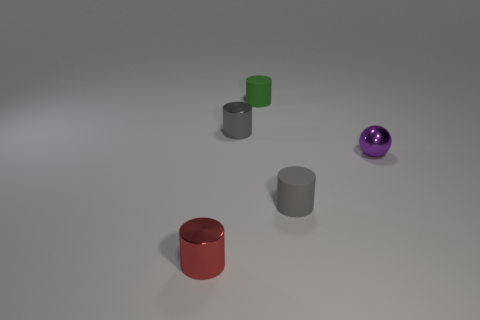Subtract all tiny gray metal cylinders. How many cylinders are left? 3 Subtract all brown blocks. How many gray cylinders are left? 2 Subtract all red cylinders. How many cylinders are left? 3 Subtract all cylinders. How many objects are left? 1 Add 2 shiny things. How many objects exist? 7 Subtract 0 red spheres. How many objects are left? 5 Subtract all brown cylinders. Subtract all brown cubes. How many cylinders are left? 4 Subtract all large blue shiny blocks. Subtract all small purple objects. How many objects are left? 4 Add 2 red cylinders. How many red cylinders are left? 3 Add 2 tiny matte objects. How many tiny matte objects exist? 4 